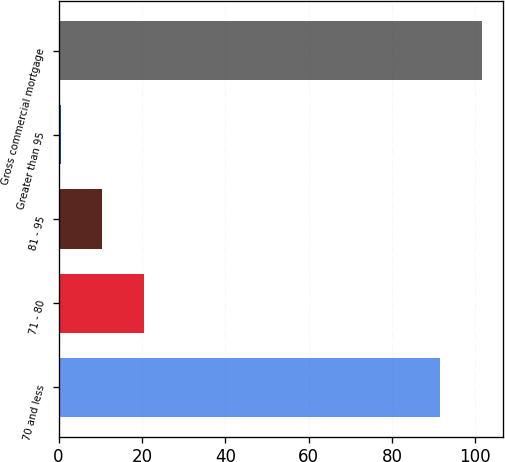Convert chart. <chart><loc_0><loc_0><loc_500><loc_500><bar_chart><fcel>70 and less<fcel>71 - 80<fcel>81 - 95<fcel>Greater than 95<fcel>Gross commercial mortgage<nl><fcel>91.6<fcel>20.4<fcel>10.45<fcel>0.5<fcel>101.55<nl></chart> 